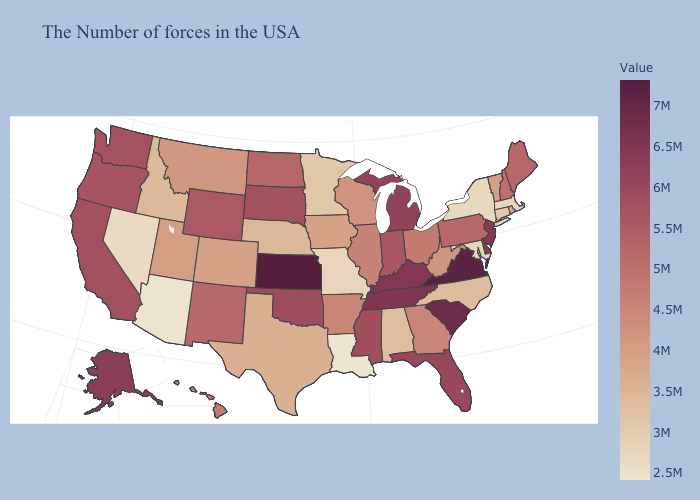Among the states that border Colorado , which have the highest value?
Give a very brief answer. Kansas. Does North Carolina have the highest value in the South?
Give a very brief answer. No. Among the states that border Massachusetts , does Vermont have the highest value?
Write a very short answer. No. Which states have the highest value in the USA?
Be succinct. Kansas. Does Rhode Island have the highest value in the USA?
Give a very brief answer. No. Among the states that border Nebraska , does Kansas have the lowest value?
Concise answer only. No. 